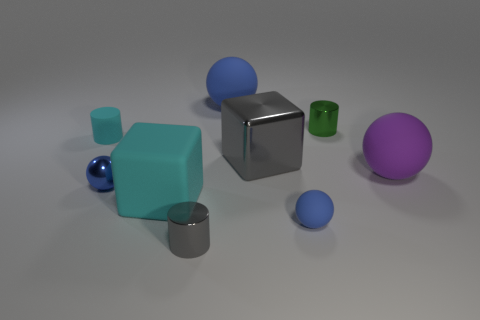Subtract all big purple balls. How many balls are left? 3 Add 1 large cyan matte things. How many objects exist? 10 Subtract all gray cylinders. How many blue balls are left? 3 Subtract all purple balls. How many balls are left? 3 Subtract 0 blue blocks. How many objects are left? 9 Subtract all cylinders. How many objects are left? 6 Subtract all red spheres. Subtract all purple blocks. How many spheres are left? 4 Subtract all gray things. Subtract all small green objects. How many objects are left? 6 Add 2 small green shiny cylinders. How many small green shiny cylinders are left? 3 Add 7 small cyan matte blocks. How many small cyan matte blocks exist? 7 